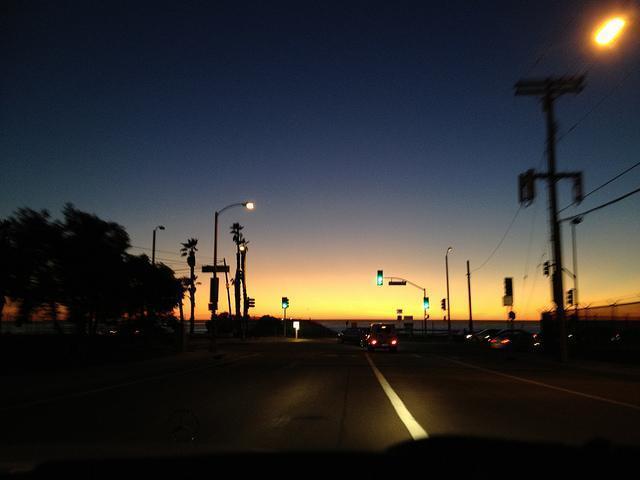How many people are wearing helmets?
Give a very brief answer. 0. 